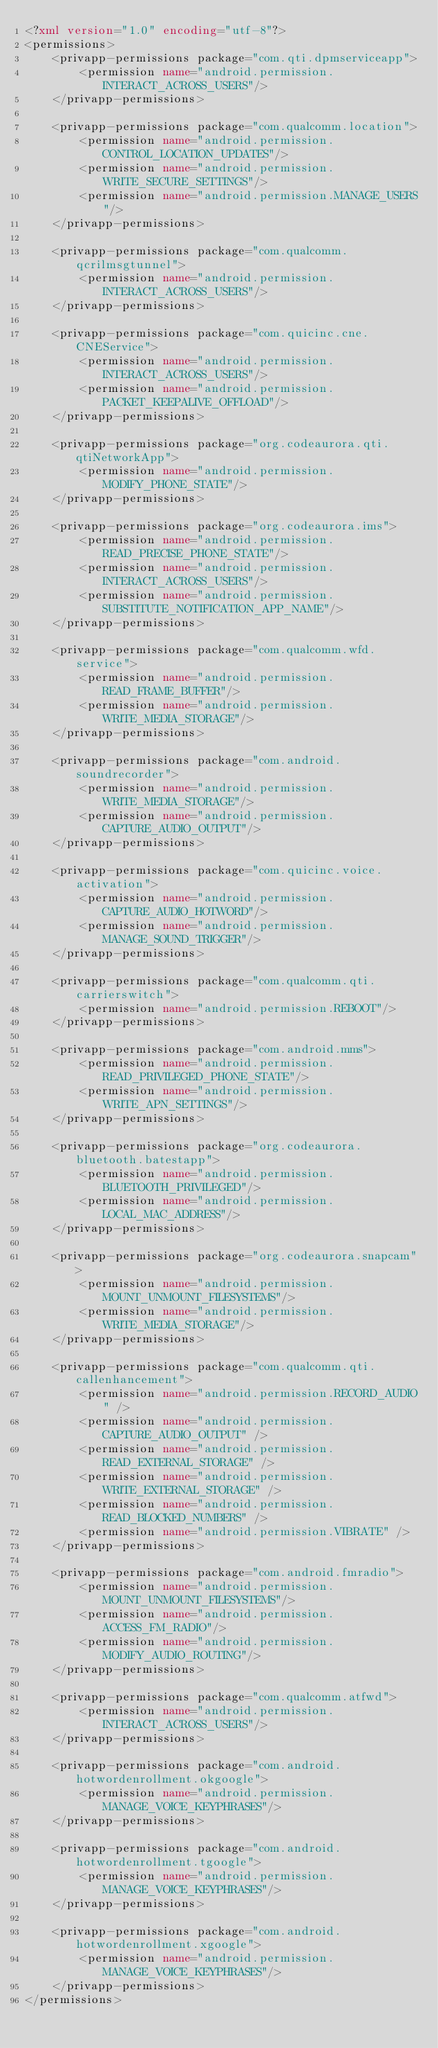Convert code to text. <code><loc_0><loc_0><loc_500><loc_500><_XML_><?xml version="1.0" encoding="utf-8"?>
<permissions>
    <privapp-permissions package="com.qti.dpmserviceapp">
        <permission name="android.permission.INTERACT_ACROSS_USERS"/>
    </privapp-permissions>

    <privapp-permissions package="com.qualcomm.location">
        <permission name="android.permission.CONTROL_LOCATION_UPDATES"/>
        <permission name="android.permission.WRITE_SECURE_SETTINGS"/>
        <permission name="android.permission.MANAGE_USERS"/>
    </privapp-permissions>

    <privapp-permissions package="com.qualcomm.qcrilmsgtunnel">
        <permission name="android.permission.INTERACT_ACROSS_USERS"/>
    </privapp-permissions>

    <privapp-permissions package="com.quicinc.cne.CNEService">
        <permission name="android.permission.INTERACT_ACROSS_USERS"/>
        <permission name="android.permission.PACKET_KEEPALIVE_OFFLOAD"/>
    </privapp-permissions>

    <privapp-permissions package="org.codeaurora.qti.qtiNetworkApp">
        <permission name="android.permission.MODIFY_PHONE_STATE"/>
    </privapp-permissions>

    <privapp-permissions package="org.codeaurora.ims">
        <permission name="android.permission.READ_PRECISE_PHONE_STATE"/>
        <permission name="android.permission.INTERACT_ACROSS_USERS"/>
        <permission name="android.permission.SUBSTITUTE_NOTIFICATION_APP_NAME"/>
    </privapp-permissions>

    <privapp-permissions package="com.qualcomm.wfd.service">
        <permission name="android.permission.READ_FRAME_BUFFER"/>
        <permission name="android.permission.WRITE_MEDIA_STORAGE"/>
    </privapp-permissions>

    <privapp-permissions package="com.android.soundrecorder">
        <permission name="android.permission.WRITE_MEDIA_STORAGE"/>
        <permission name="android.permission.CAPTURE_AUDIO_OUTPUT"/>
    </privapp-permissions>

    <privapp-permissions package="com.quicinc.voice.activation">
        <permission name="android.permission.CAPTURE_AUDIO_HOTWORD"/>
        <permission name="android.permission.MANAGE_SOUND_TRIGGER"/>
    </privapp-permissions>

    <privapp-permissions package="com.qualcomm.qti.carrierswitch">
        <permission name="android.permission.REBOOT"/>
    </privapp-permissions>

    <privapp-permissions package="com.android.mms">
        <permission name="android.permission.READ_PRIVILEGED_PHONE_STATE"/>
        <permission name="android.permission.WRITE_APN_SETTINGS"/>
    </privapp-permissions>

    <privapp-permissions package="org.codeaurora.bluetooth.batestapp">
        <permission name="android.permission.BLUETOOTH_PRIVILEGED"/>
        <permission name="android.permission.LOCAL_MAC_ADDRESS"/>
    </privapp-permissions>

    <privapp-permissions package="org.codeaurora.snapcam">
        <permission name="android.permission.MOUNT_UNMOUNT_FILESYSTEMS"/>
        <permission name="android.permission.WRITE_MEDIA_STORAGE"/>
    </privapp-permissions>

    <privapp-permissions package="com.qualcomm.qti.callenhancement">
        <permission name="android.permission.RECORD_AUDIO" />
        <permission name="android.permission.CAPTURE_AUDIO_OUTPUT" />
        <permission name="android.permission.READ_EXTERNAL_STORAGE" />
        <permission name="android.permission.WRITE_EXTERNAL_STORAGE" />
        <permission name="android.permission.READ_BLOCKED_NUMBERS" />
        <permission name="android.permission.VIBRATE" />
    </privapp-permissions>

    <privapp-permissions package="com.android.fmradio">
        <permission name="android.permission.MOUNT_UNMOUNT_FILESYSTEMS"/>
        <permission name="android.permission.ACCESS_FM_RADIO"/>
        <permission name="android.permission.MODIFY_AUDIO_ROUTING"/>
    </privapp-permissions>

    <privapp-permissions package="com.qualcomm.atfwd">
        <permission name="android.permission.INTERACT_ACROSS_USERS"/>
    </privapp-permissions>

    <privapp-permissions package="com.android.hotwordenrollment.okgoogle">
        <permission name="android.permission.MANAGE_VOICE_KEYPHRASES"/>
    </privapp-permissions>

    <privapp-permissions package="com.android.hotwordenrollment.tgoogle">
        <permission name="android.permission.MANAGE_VOICE_KEYPHRASES"/>
    </privapp-permissions>

    <privapp-permissions package="com.android.hotwordenrollment.xgoogle">
        <permission name="android.permission.MANAGE_VOICE_KEYPHRASES"/>           
    </privapp-permissions>
</permissions>
</code> 